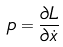<formula> <loc_0><loc_0><loc_500><loc_500>p = \frac { \partial L } { \partial \dot { x } }</formula> 